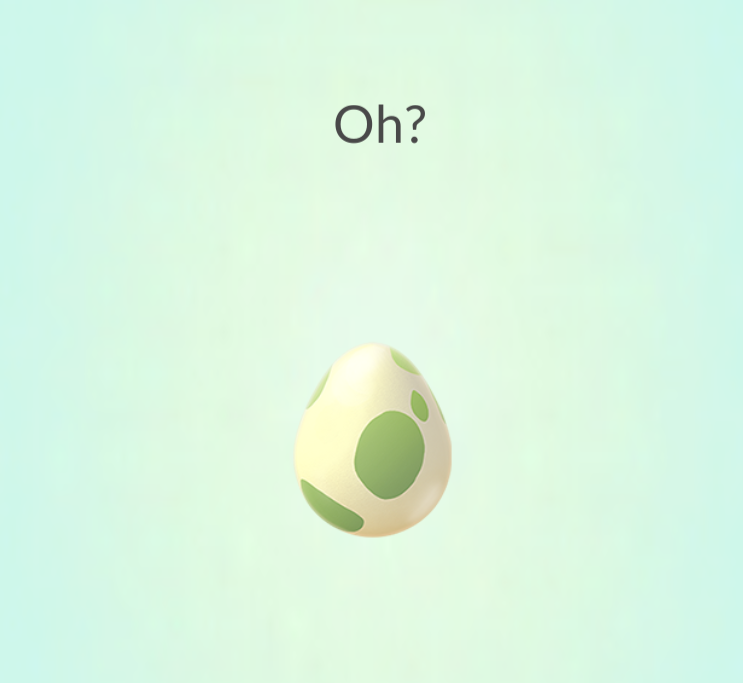What type of creature do you think will hatch from this egg? Given the gentle green and white design of the egg, it's likely that a creature embodying softness and nature, such as a small, friendly dragon or a mystical forest creature, will emerge. The anticipation is set to mirror the excitement of uncovering new, magical elements within the game. 